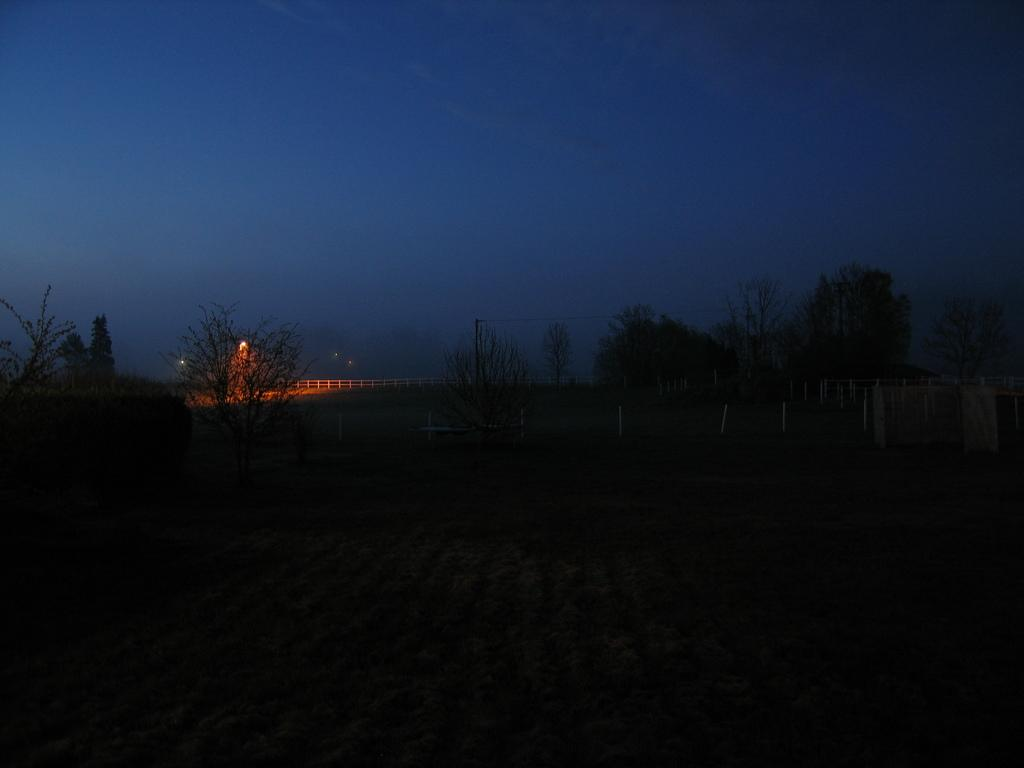What is the main feature of the image? There are many trees in the image. Can you describe any man-made structures in the image? Yes, there is a railing in the image. What type of illumination is present in the image? There is a light in the image. What can be seen in the background of the image? The sky is visible in the background of the image. How many years does the squirrel in the image have? There is no squirrel present in the image. What type of powder is used to create the light in the image? There is no mention of powder being used to create the light in the image; it is likely an electric light source. 